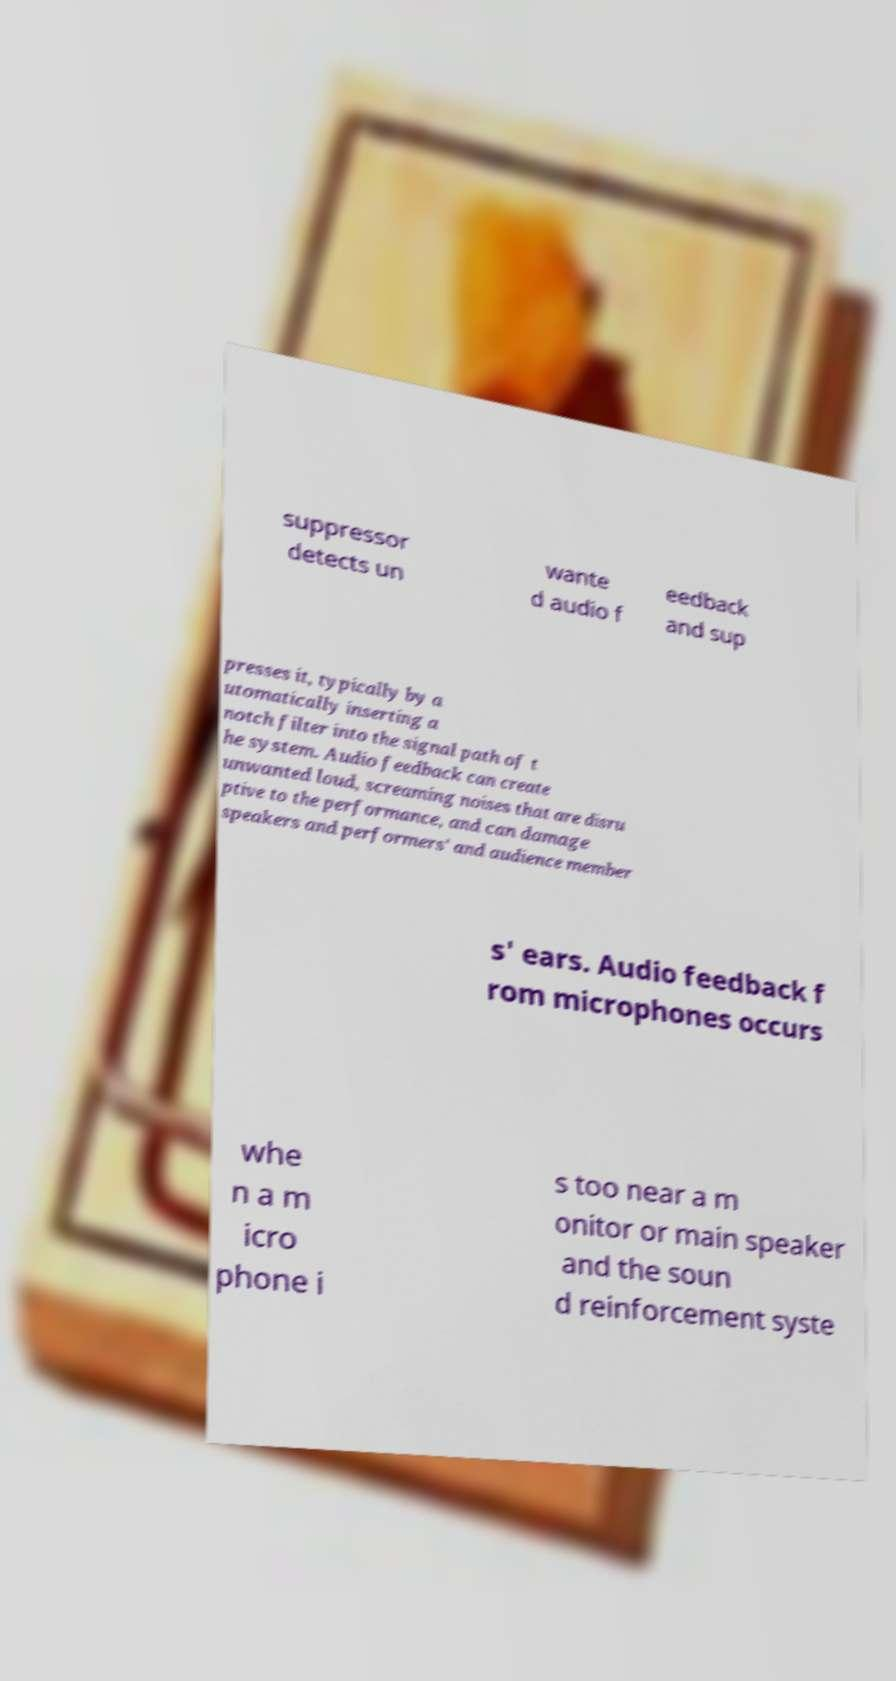I need the written content from this picture converted into text. Can you do that? suppressor detects un wante d audio f eedback and sup presses it, typically by a utomatically inserting a notch filter into the signal path of t he system. Audio feedback can create unwanted loud, screaming noises that are disru ptive to the performance, and can damage speakers and performers' and audience member s' ears. Audio feedback f rom microphones occurs whe n a m icro phone i s too near a m onitor or main speaker and the soun d reinforcement syste 